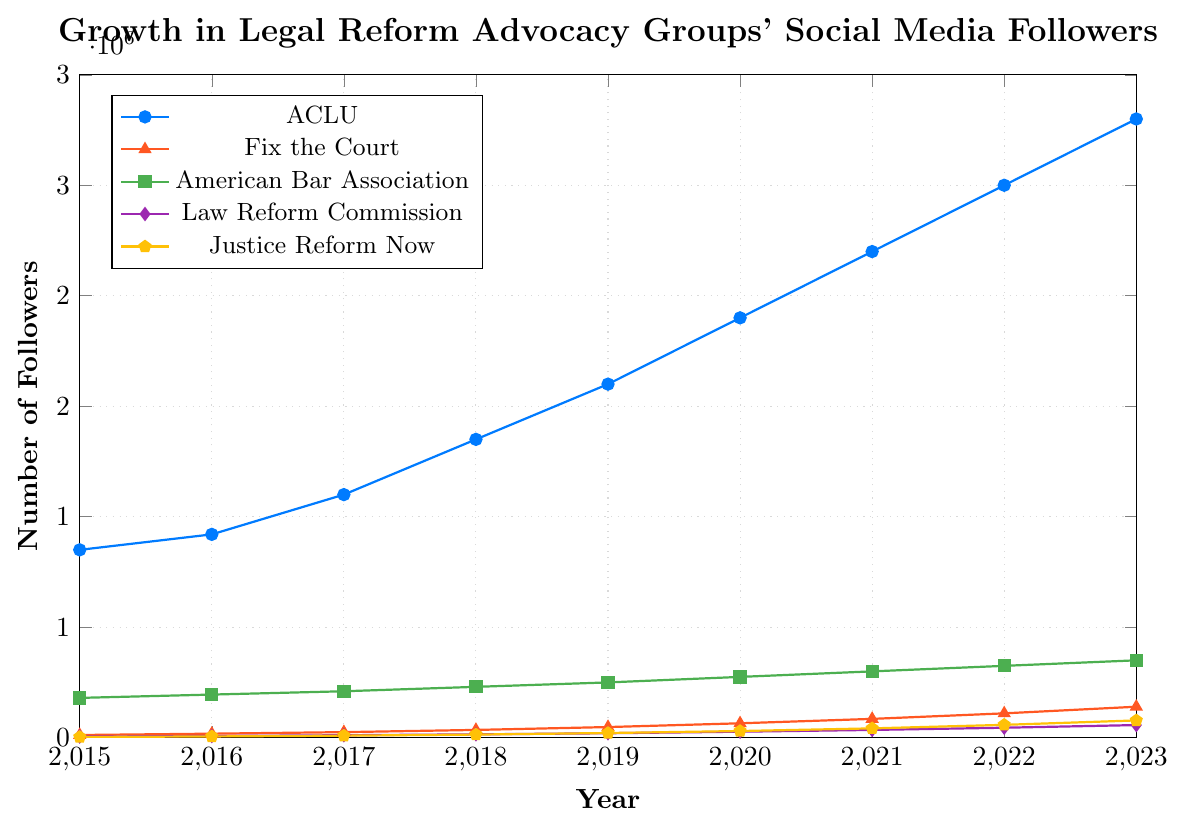Which year had the highest number of followers for the ACLU? Look at the ACLU line and find the highest point. The highest number of followers for the ACLU occurs in 2023 with 2,800,000 followers.
Answer: 2023 How many more followers did Justice Reform Now have in 2023 compared to 2015? Subtract the number of followers in 2015 from the number of followers in 2023 for Justice Reform Now. 78,000 (2023) - 3,000 (2015) = 75,000.
Answer: 75,000 What is the average number of followers for the Law Reform Commission across all years? Sum all the numbers of followers for the Law Reform Commission from 2015 to 2023 and divide by the number of years (9). (5,000 + 7,500 + 11,000 + 15,000 + 20,000 + 27,000 + 35,000 + 45,000 + 57,000) / 9 = 24,500.
Answer: 24,500 Which organization saw the greatest increase in followers between 2015 and 2023? Calculate the difference between 2023 and 2015 for each organization and compare. ACLU: 2,800,000 - 850,000 = 1,950,000; Fix the Court: 140,000 - 12,000 = 128,000; American Bar Association: 350,000 - 180,000 = 170,000; Law Reform Commission: 57,000 - 5,000 = 52,000; Justice Reform Now: 78,000 - 3,000 = 75,000. The ACLU had the greatest increase.
Answer: ACLU In what year did Fix the Court surpass 50,000 followers? Look along the Fix the Court line and identify the first year it is greater than 50,000. That year is 2019 with 48,000 just below, and 2020 with 65,000 above.
Answer: 2020 By how much did the American Bar Association followers increase in 2021? Subtract the number of followers in 2020 from the number in 2021 for the American Bar Association. 300,000 (2021) - 275,000 (2020) = 25,000.
Answer: 25,000 What is the combined total number of followers for all organizations in 2018? Add the number of followers for each organization in 2018. 1,350,000 (ACLU) + 35,000 (Fix the Court) + 230,000 (American Bar Association) + 15,000 (Law Reform Commission) + 14,000 (Justice Reform Now) = 1,644,000.
Answer: 1,644,000 